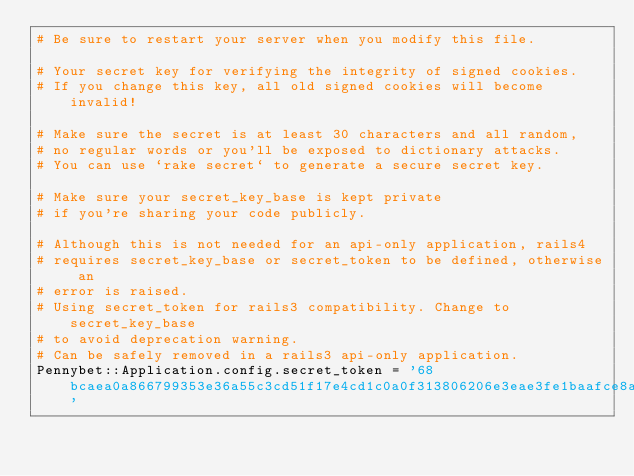<code> <loc_0><loc_0><loc_500><loc_500><_Ruby_># Be sure to restart your server when you modify this file.

# Your secret key for verifying the integrity of signed cookies.
# If you change this key, all old signed cookies will become invalid!

# Make sure the secret is at least 30 characters and all random,
# no regular words or you'll be exposed to dictionary attacks.
# You can use `rake secret` to generate a secure secret key.

# Make sure your secret_key_base is kept private
# if you're sharing your code publicly.

# Although this is not needed for an api-only application, rails4 
# requires secret_key_base or secret_token to be defined, otherwise an 
# error is raised.
# Using secret_token for rails3 compatibility. Change to secret_key_base
# to avoid deprecation warning.
# Can be safely removed in a rails3 api-only application.
Pennybet::Application.config.secret_token = '68bcaea0a866799353e36a55c3cd51f17e4cd1c0a0f313806206e3eae3fe1baafce8a17313c991acf00440b253fb95a0fed89cf8f4fed24de22e1662042f19bb'
</code> 